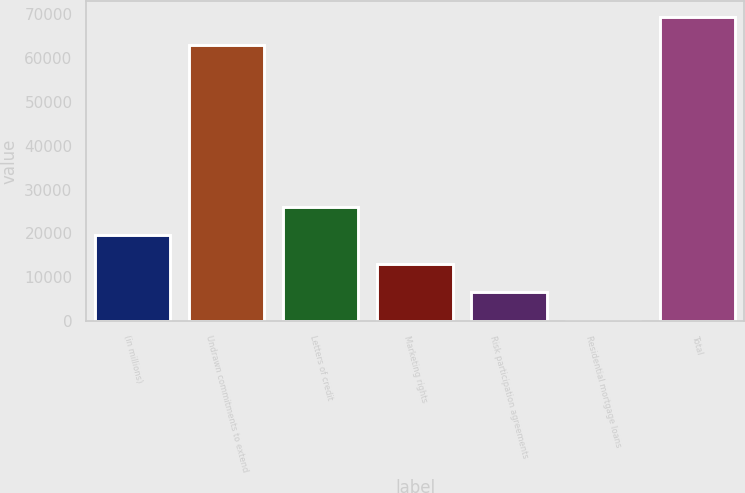Convert chart. <chart><loc_0><loc_0><loc_500><loc_500><bar_chart><fcel>(in millions)<fcel>Undrawn commitments to extend<fcel>Letters of credit<fcel>Marketing rights<fcel>Risk participation agreements<fcel>Residential mortgage loans<fcel>Total<nl><fcel>19552.6<fcel>62959<fcel>26067.8<fcel>13037.4<fcel>6522.2<fcel>7<fcel>69474.2<nl></chart> 